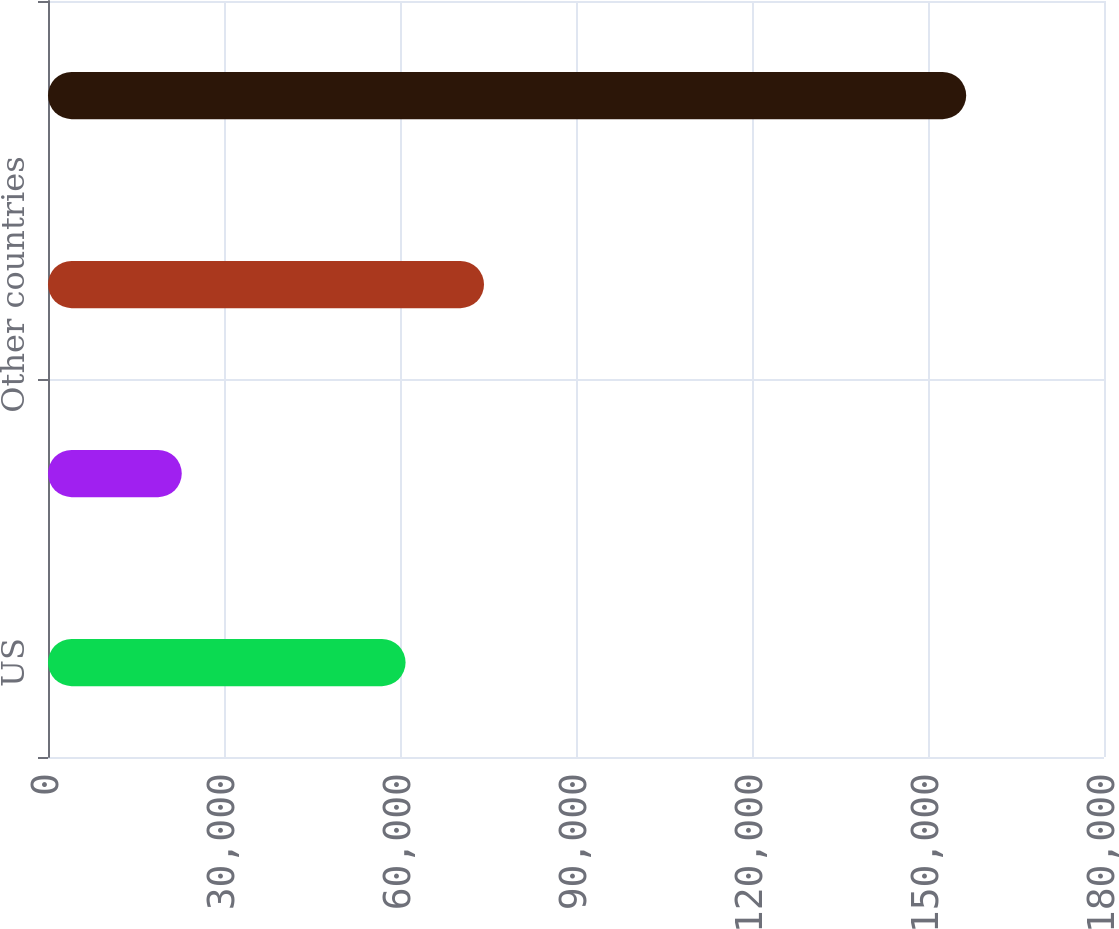Convert chart to OTSL. <chart><loc_0><loc_0><loc_500><loc_500><bar_chart><fcel>US<fcel>China (a)<fcel>Other countries<fcel>Total net sales<nl><fcel>60949<fcel>22797<fcel>74320.1<fcel>156508<nl></chart> 